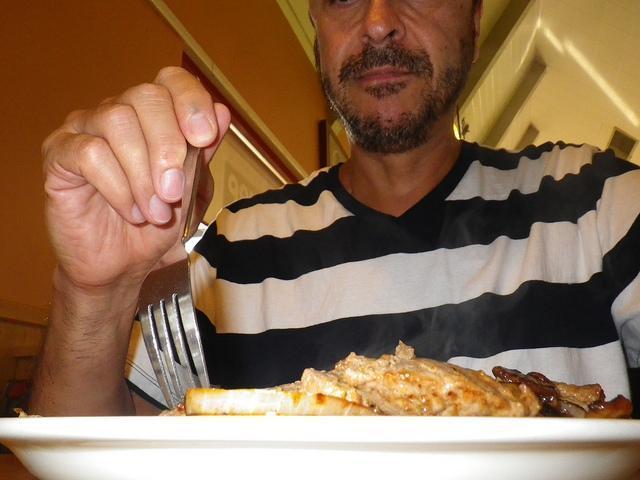How many horses can be seen?
Give a very brief answer. 0. 